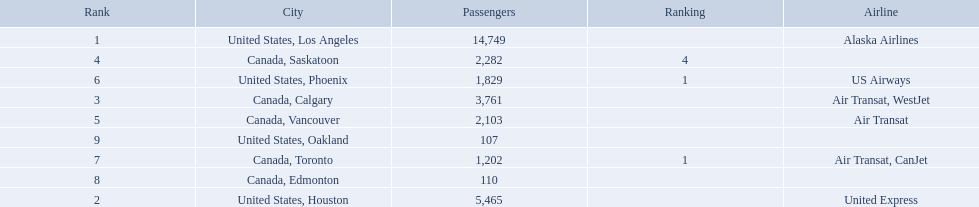What were all the passenger totals? 14,749, 5,465, 3,761, 2,282, 2,103, 1,829, 1,202, 110, 107. Which of these were to los angeles? 14,749. What other destination combined with this is closest to 19,000? Canada, Calgary. What cities do the planes fly to? United States, Los Angeles, United States, Houston, Canada, Calgary, Canada, Saskatoon, Canada, Vancouver, United States, Phoenix, Canada, Toronto, Canada, Edmonton, United States, Oakland. How many people are flying to phoenix, arizona? 1,829. 